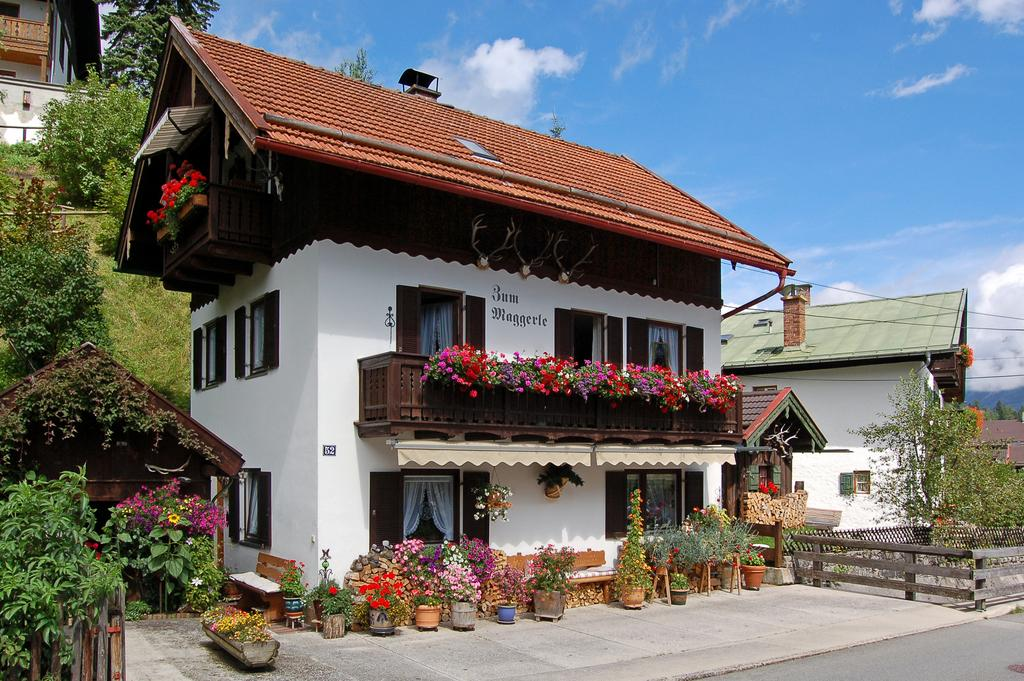What type of plants can be seen in the image? There are house plants in the image. What type of furniture is present in the image? There are benches on the floor in the image. What type of barrier can be seen in the image? There are fences in the image. What type of pathway is visible in the image? There is a road in the image. What type of structures are present in the image? There are buildings in the image. What type of openings can be seen in the buildings? There are windows in the image. What type of window treatment is present in the image? There are curtains in the image. What type of natural vegetation is visible in the image? There are trees in the image. What type of objects can be seen in the image? There are some objects in the image. What can be seen in the background of the image? The sky with clouds is visible in the background of the image. How many legs does the adjustment have in the image? There is no adjustment present in the image, so it does not have any legs. What type of show can be seen on the benches in the image? There is no show present in the image; it only features benches, house plants, and other objects. 